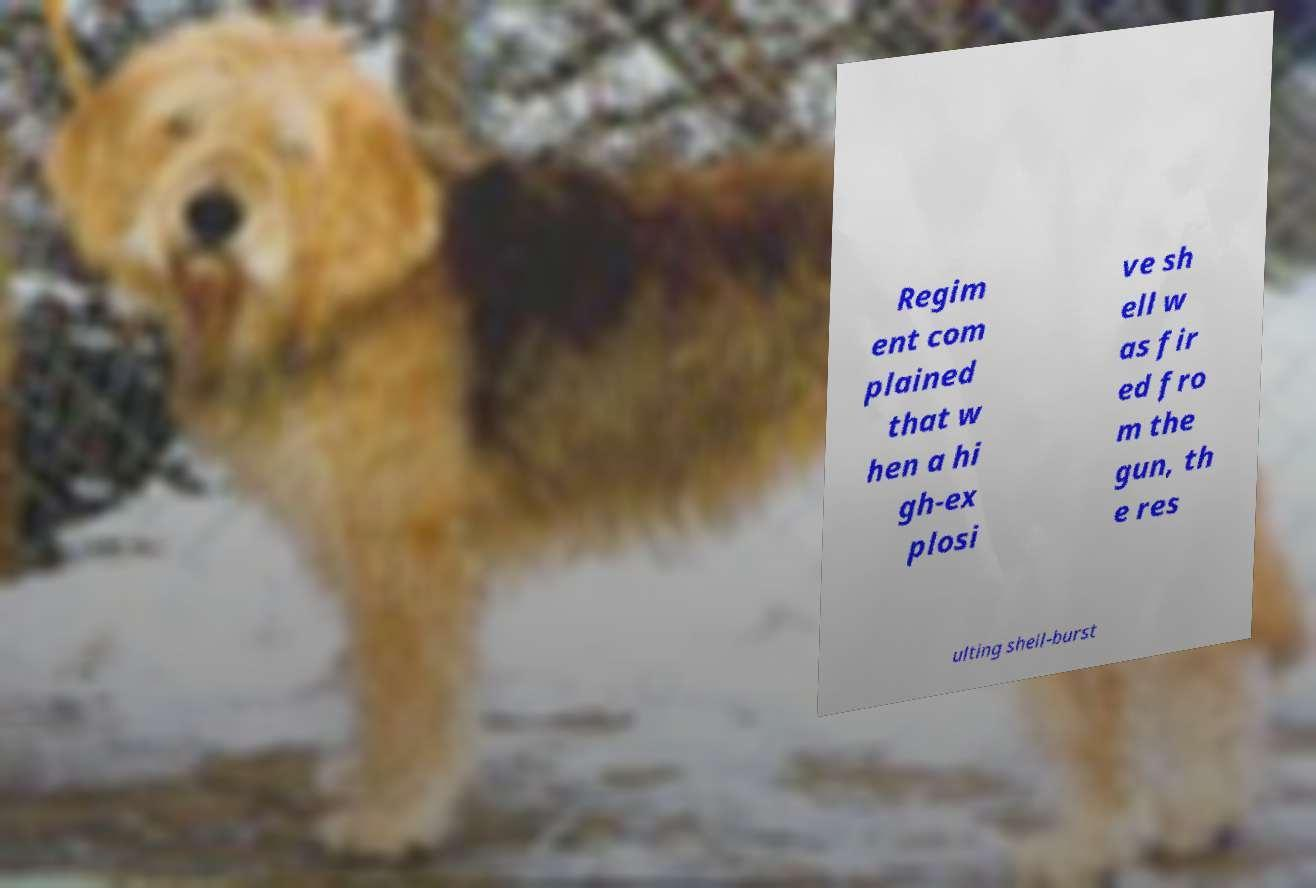Can you accurately transcribe the text from the provided image for me? Regim ent com plained that w hen a hi gh-ex plosi ve sh ell w as fir ed fro m the gun, th e res ulting shell-burst 